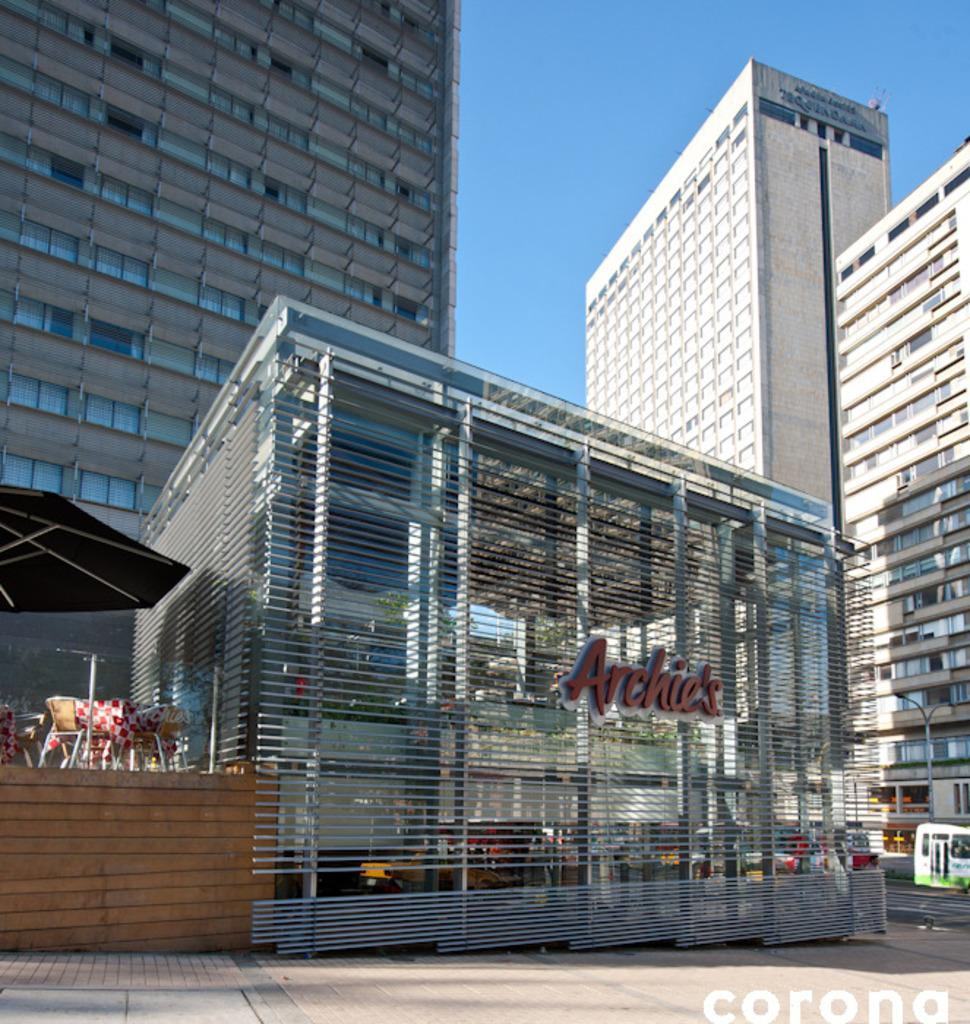What structures can be seen in the image? There are buildings in the image. What part of the natural environment is visible in the image? The sky is visible at the top of the image. How does the uncle compare the buildings in the image? There is no uncle present in the image, and therefore no comparison can be made. What type of balls can be seen in the image? There are no balls present in the image. 